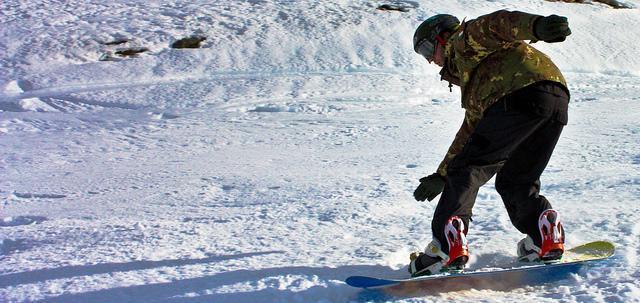How many horses are there?
Give a very brief answer. 0. 